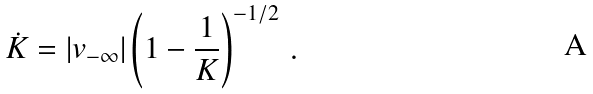Convert formula to latex. <formula><loc_0><loc_0><loc_500><loc_500>\dot { K } = | v _ { - \infty } | \left ( 1 - \frac { 1 } { K } \right ) ^ { - 1 / 2 } \, .</formula> 